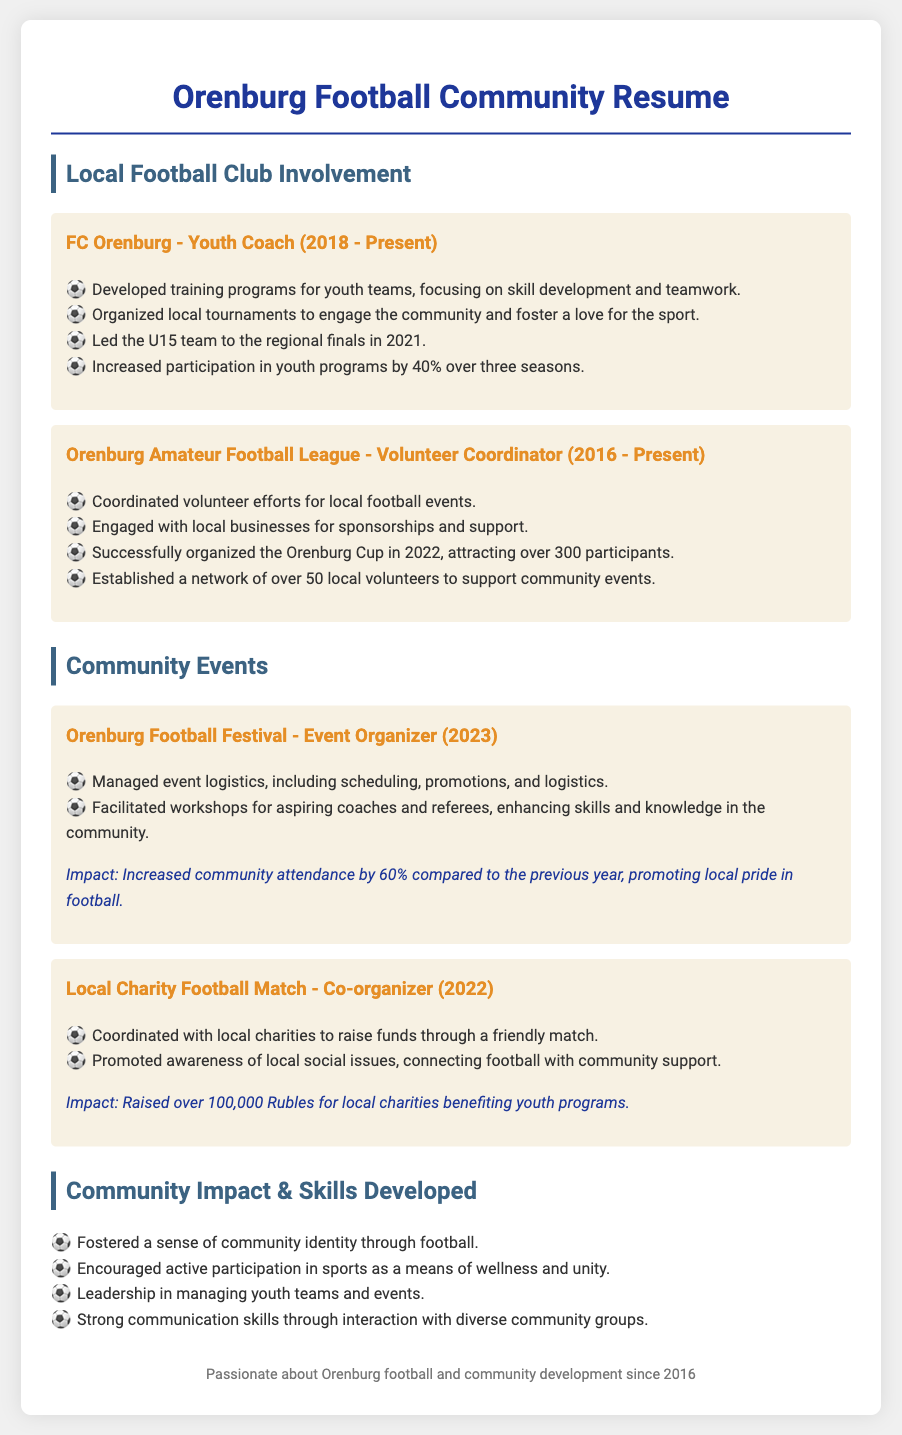What is the role held at FC Orenburg? The document states that the role held is Youth Coach.
Answer: Youth Coach In what year did the U15 team reach the regional finals? The document indicates that the U15 team achieved this milestone in 2021.
Answer: 2021 What was the percentage increase in youth program participation over three seasons? The document reports an increase of 40% in participation.
Answer: 40% How many participants were attracted to the Orenburg Cup in 2022? The document states that it attracted over 300 participants.
Answer: Over 300 participants What was the total amount raised for local charities in 2022? According to the document, over 100,000 Rubles were raised.
Answer: Over 100,000 Rubles What is the impact of the Orenburg Football Festival on community attendance compared to the previous year? The document states that attendance increased by 60%.
Answer: 60% Who coordinated the local charity football match? The document mentions that the role of Co-organizer was held for this match.
Answer: Co-organizer What community skill is emphasized through managing youth teams? The document highlights leadership as a key skill developed in this area.
Answer: Leadership Since when has the individual been passionate about Orenburg football and community development? The document specifies the year 2016 as the starting point of this passion.
Answer: 2016 